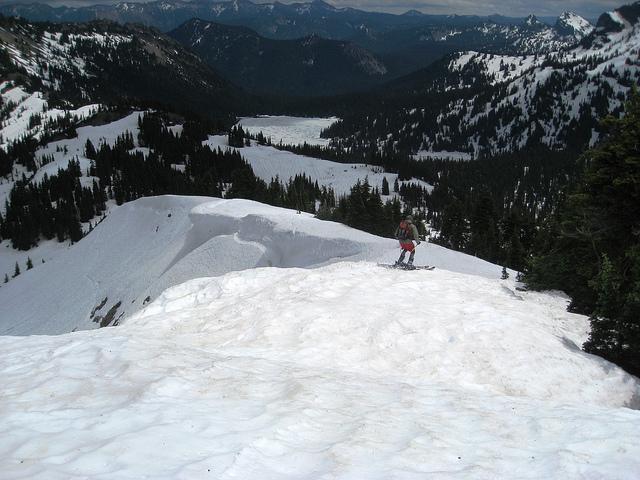From where did this person directly come?
Make your selection and explain in format: 'Answer: answer
Rationale: rationale.'
Options: Up high, sun valley, below, ski lodge. Answer: up high.
Rationale: The person skiing on the mountain was higher up and skied to their location. 